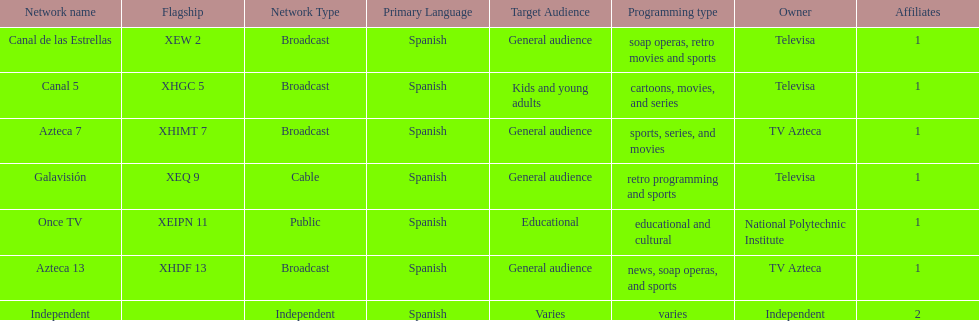How many networks do not air sports? 2. 